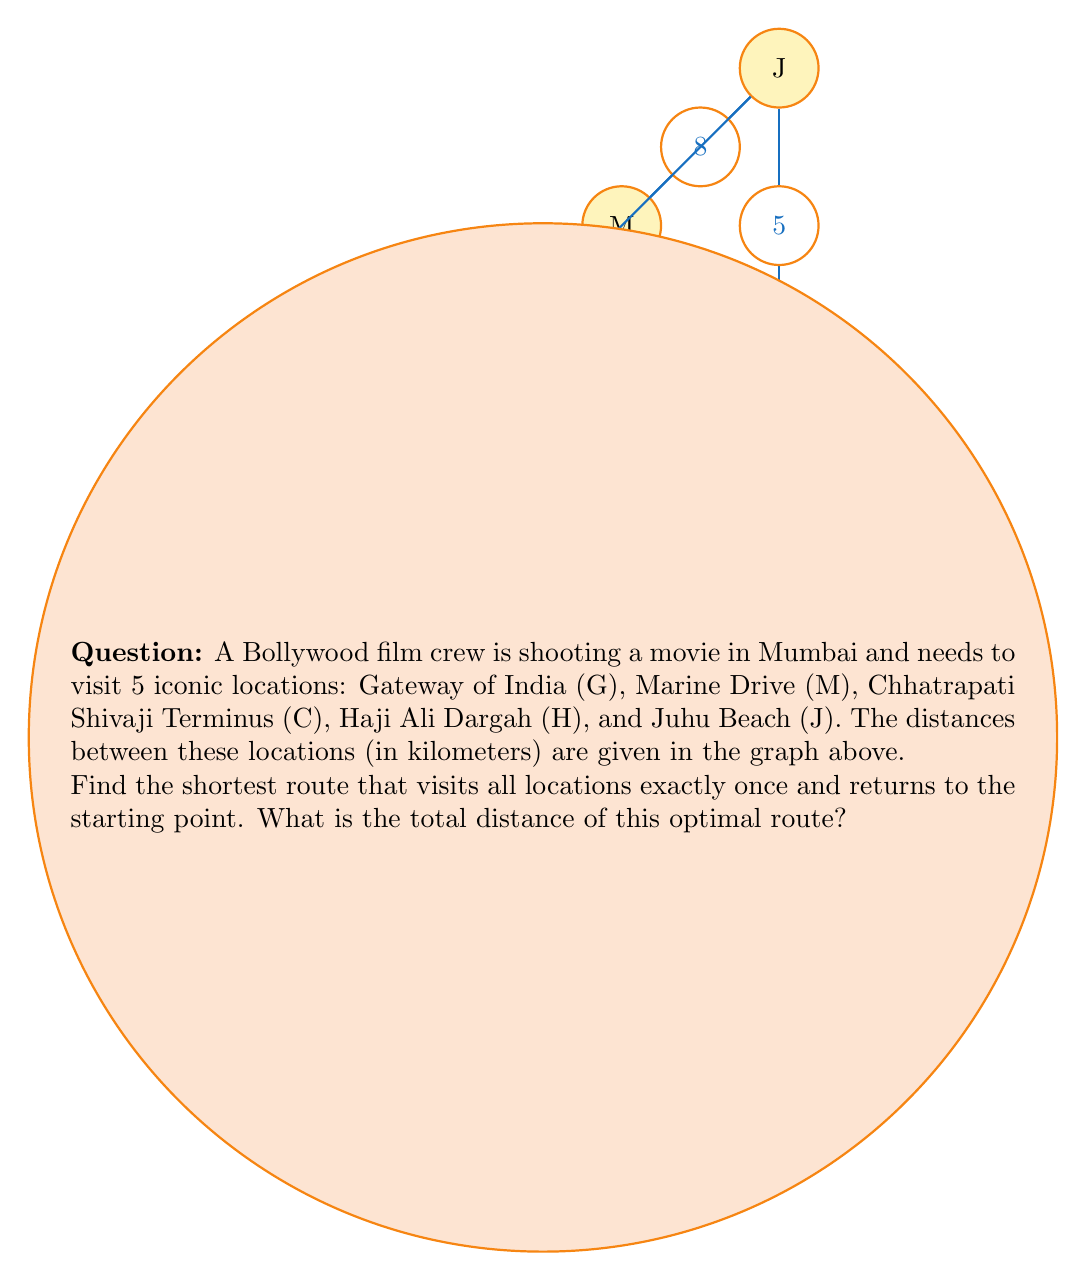What is the answer to this math problem? This problem is an instance of the Traveling Salesman Problem (TSP), which is NP-hard. For small instances like this, we can solve it using brute force.

1) First, we list all possible permutations of the 5 locations. There are 5! = 120 permutations.

2) For each permutation, we calculate the total distance, including the return to the starting point.

3) We select the permutation with the minimum total distance.

Let's consider one possible route: G -> M -> C -> J -> H -> G

Distance = $d_{GM} + d_{MC} + d_{CJ} + d_{JH} + d_{HG}$
         = $5 + 4 + 5 + 9 + 7 = 30$ km

We would need to check all 120 permutations to find the optimal route. After doing so, we find that the optimal route is:

G -> H -> M -> J -> C -> G

The total distance for this route is:

$d_{GH} + d_{HM} + d_{MJ} + d_{JC} + d_{CG} = 7 + 3 + 8 + 5 + 6 = 29$ km

This is the shortest possible route that visits all locations once and returns to the starting point.
Answer: 29 km 